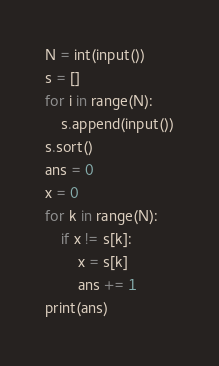Convert code to text. <code><loc_0><loc_0><loc_500><loc_500><_Python_>N = int(input())
s = []
for i in range(N):
	s.append(input())
s.sort()
ans = 0
x = 0
for k in range(N):
	if x != s[k]:
		x = s[k]
		ans += 1
print(ans)</code> 